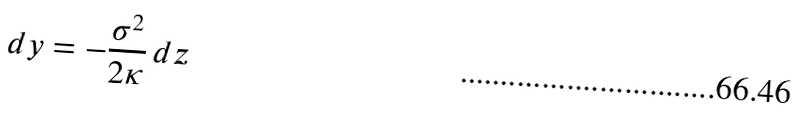Convert formula to latex. <formula><loc_0><loc_0><loc_500><loc_500>d y = - \frac { \sigma ^ { 2 } } { 2 \kappa } \, d z</formula> 